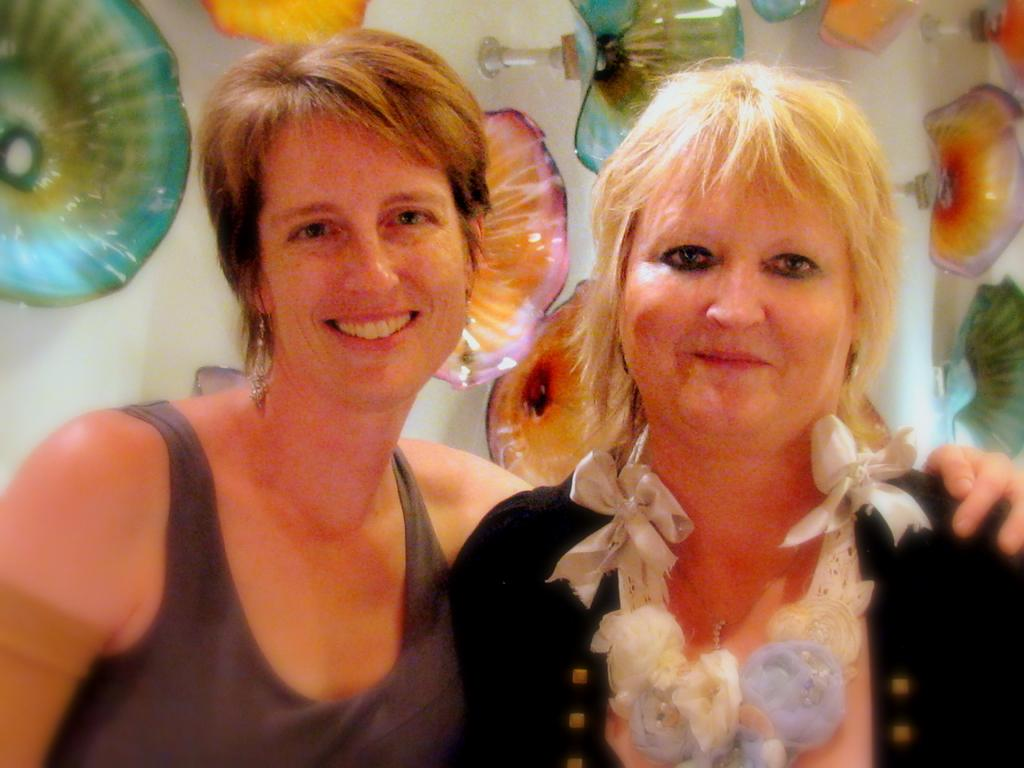How many people are in the image? There are two women in the image. What are the women doing in the image? The women are standing together and smiling. What can be seen in the background of the image? There is a wall visible in the background of the image. What is the appearance of the wall? The wall has flower designs on it. Can you tell me how many goats are visible in the image? There are no goats present in the image. What type of needle is being used by the women in the image? There is no needle visible in the image; the women are simply standing together and smiling. 